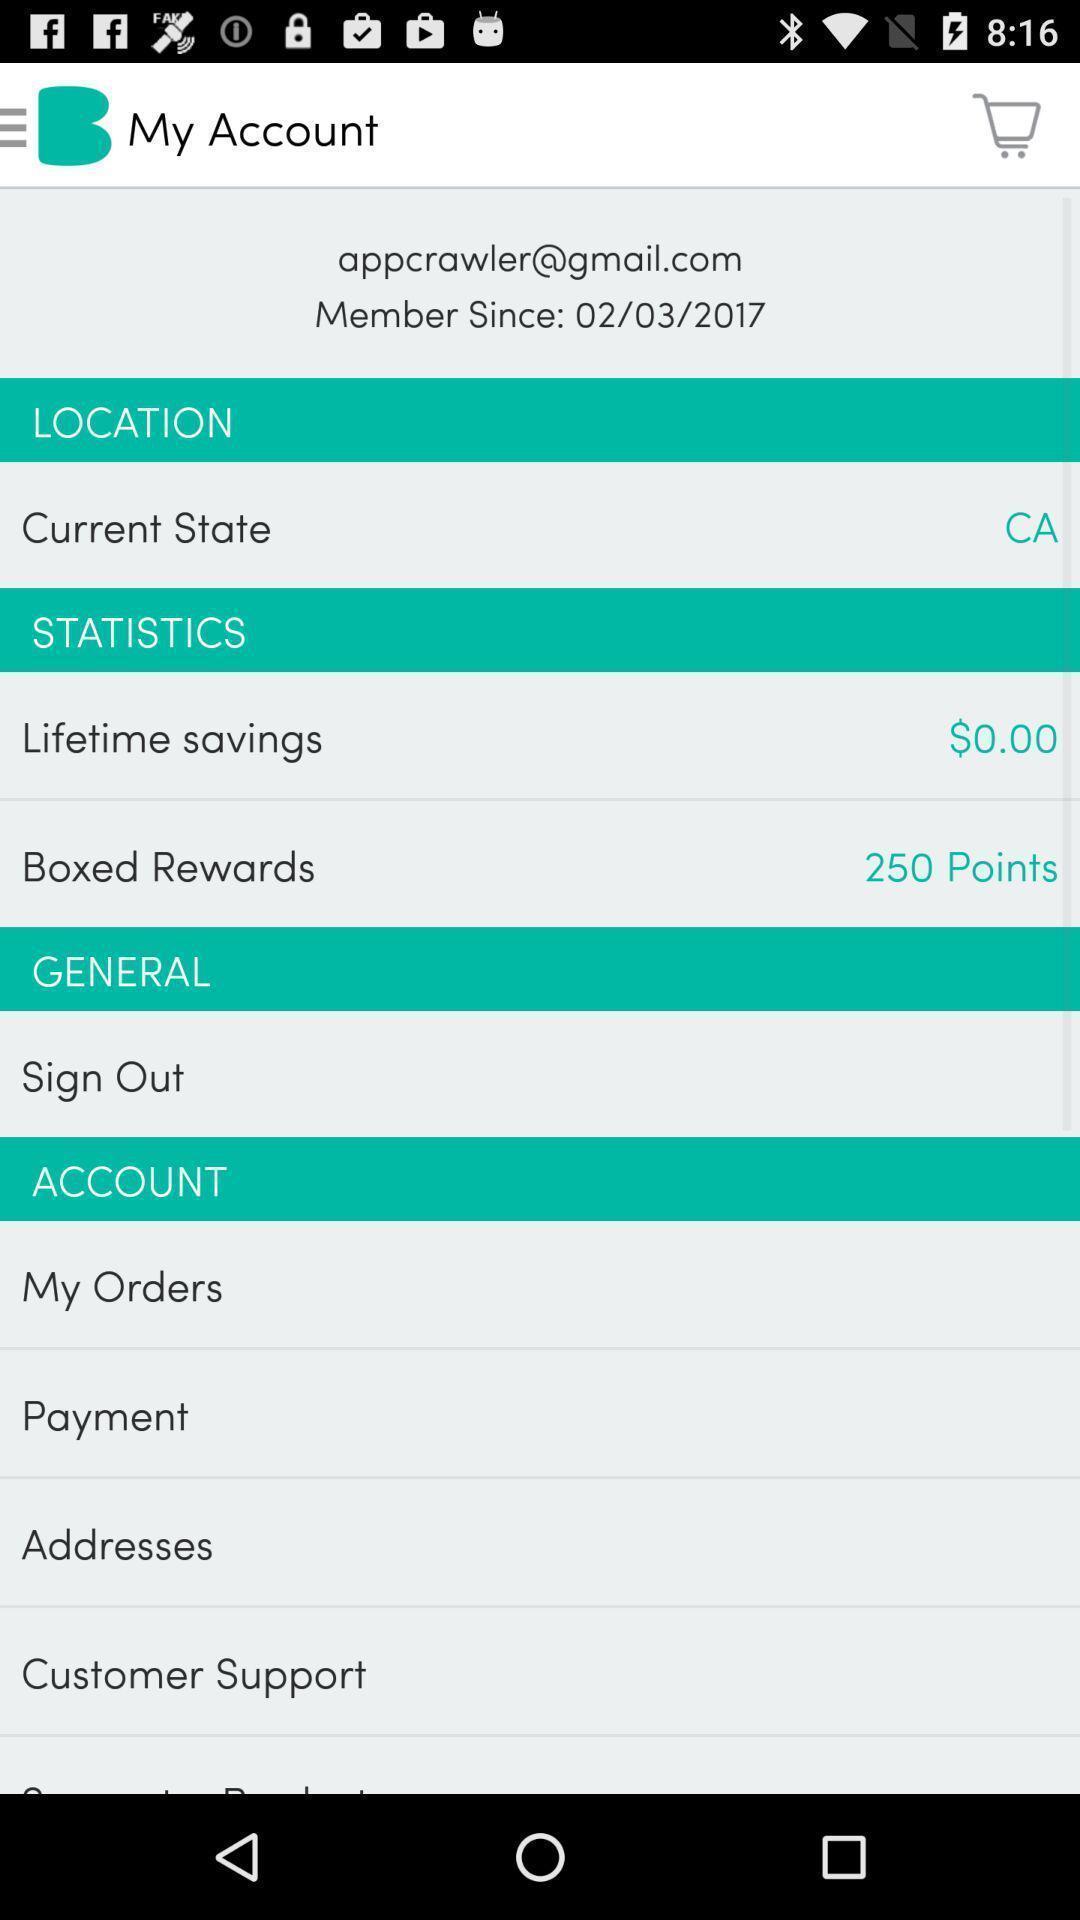Explain the elements present in this screenshot. Page showing different options in account. 